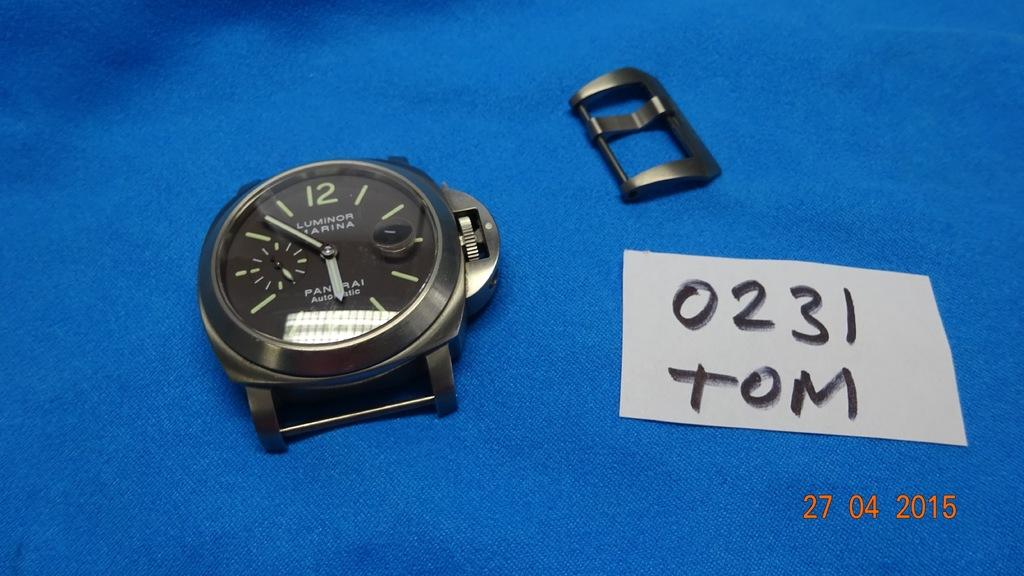Provide a one-sentence caption for the provided image. A gray metal analog watch face with a watch closure piece on a blue tarp beside a written note reading TOM. 